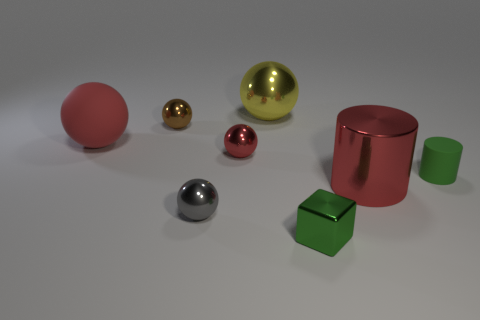Does the tiny cylinder have the same color as the metal cube?
Your answer should be compact. Yes. Is the small gray sphere made of the same material as the small cylinder?
Provide a succinct answer. No. There is a cylinder that is the same color as the rubber sphere; what is its size?
Your response must be concise. Large. Are there any red spheres that have the same material as the gray ball?
Offer a very short reply. Yes. The cylinder that is on the right side of the metal cylinder to the left of the matte thing that is in front of the red matte ball is what color?
Provide a short and direct response. Green. How many green things are either big objects or tiny cubes?
Your response must be concise. 1. What number of red rubber things have the same shape as the yellow object?
Offer a very short reply. 1. The matte object that is the same size as the gray sphere is what shape?
Offer a terse response. Cylinder. There is a tiny rubber cylinder; are there any green objects on the right side of it?
Keep it short and to the point. No. Is there a big red thing that is behind the large red thing that is left of the large yellow object?
Offer a very short reply. No. 